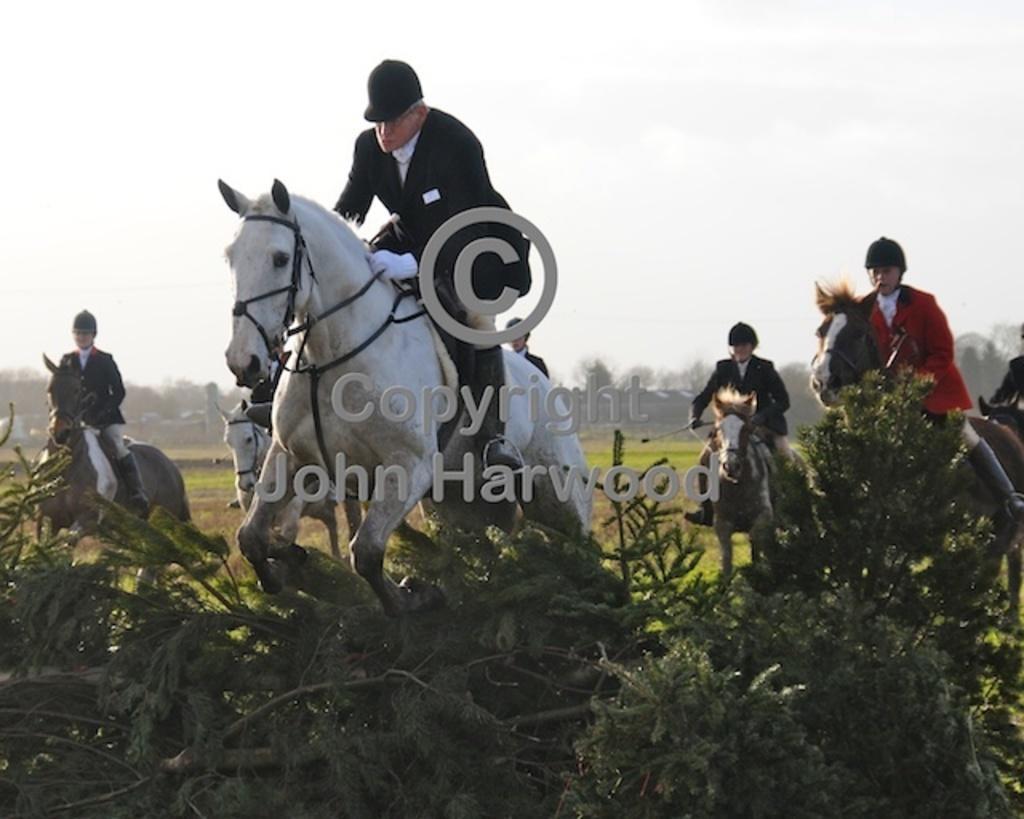Describe this image in one or two sentences. This picture shows few people riding horses and we see few plants and trees on their back and they wore a cap upon their heads and suit 